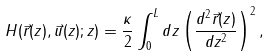Convert formula to latex. <formula><loc_0><loc_0><loc_500><loc_500>H ( \vec { r } ( z ) , \vec { u } ( z ) ; z ) = \frac { \kappa } { 2 } \int _ { 0 } ^ { L } { d z } \left ( \frac { d ^ { 2 } \vec { r } ( z ) } { d z ^ { 2 } } \right ) ^ { 2 } ,</formula> 